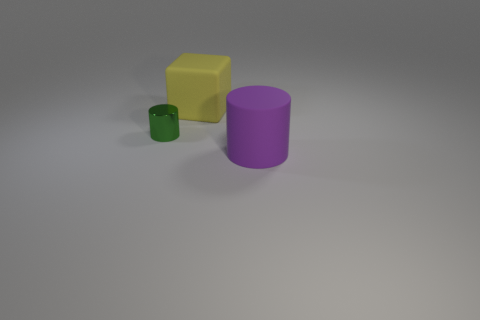How many tiny green cylinders are behind the purple thing?
Your answer should be compact. 1. How many other objects are there of the same size as the metal thing?
Provide a succinct answer. 0. Is the material of the big object that is behind the metal thing the same as the big object that is in front of the tiny shiny object?
Offer a very short reply. Yes. The other object that is the same size as the purple object is what color?
Provide a succinct answer. Yellow. Is there any other thing that is the same color as the rubber cylinder?
Give a very brief answer. No. How big is the rubber thing behind the cylinder that is behind the large object on the right side of the yellow thing?
Your answer should be compact. Large. What color is the object that is behind the purple rubber object and in front of the rubber cube?
Provide a short and direct response. Green. There is a rubber thing behind the purple cylinder; what size is it?
Your answer should be very brief. Large. What number of objects have the same material as the large block?
Give a very brief answer. 1. Is the shape of the big thing behind the small green object the same as  the purple thing?
Make the answer very short. No. 